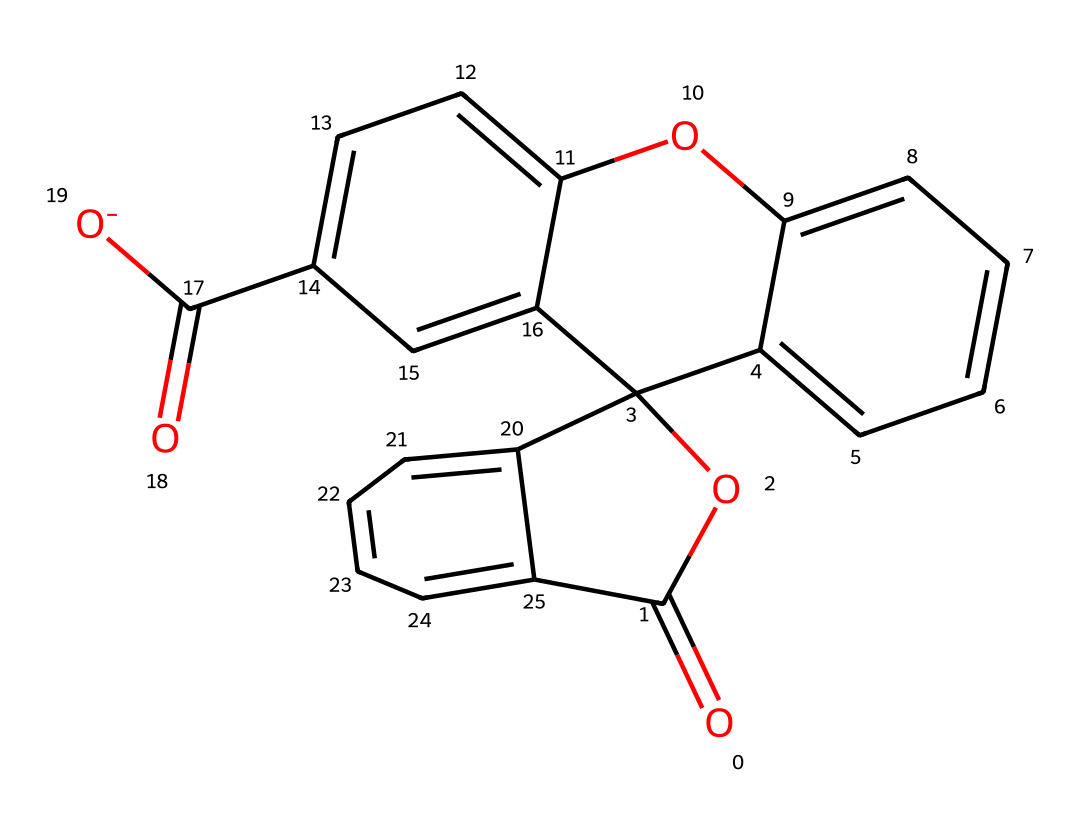What is the main functional group in this dye? The main functional group present is the carbonyl group (-C=O) which is part of the structure indicating the presence of an ester or acid functionality in the polymeric framework.
Answer: carbonyl How many rings are present in the structure? By analyzing the structure, there are two distinct fused rings in the dye, as depicted by the interconnected cyclic components of the SMILES representation.
Answer: two What type of dye is this compound classified as? This compound can be classified as a fluorescent dye due to its capacity to absorb light and emit it at a different wavelength, which is typical for fluorescent compounds.
Answer: fluorescent Which element is predominantly featured in the chromophore of this dye? The presence of conjugated systems indicated by the alternating double bonds shows that carbon atoms are predominantly featured, which form the chromophore responsible for optical properties.
Answer: carbon How many oxygen atoms are present in the entire structure? By counting the oxygen atoms in the structure as represented in the SMILES, a total of four oxygen atoms can be identified, contributing to various functional groups in the dye.
Answer: four What type of bonds predominates in this fluorescent dye? The structure contains several double bonds (C=C and C=O), indicating the predominance of covalent bonds that contribute to the stability and reactivity of the compound.
Answer: covalent 